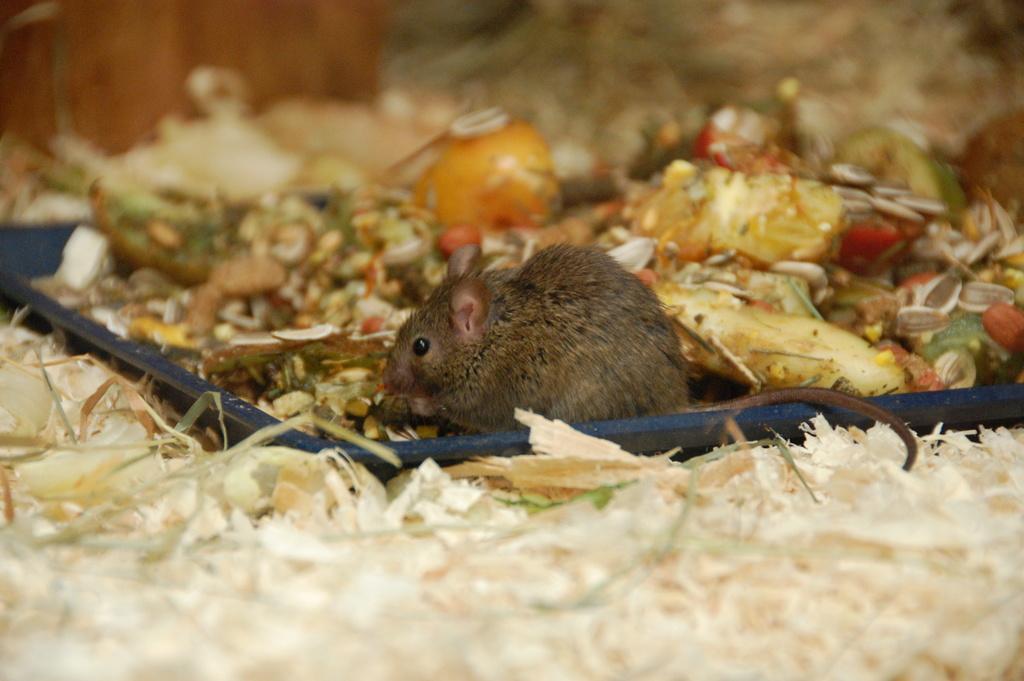Please provide a concise description of this image. In this image we can see a rat. There is a garbage in the image. A rat sitting on a garbage. 